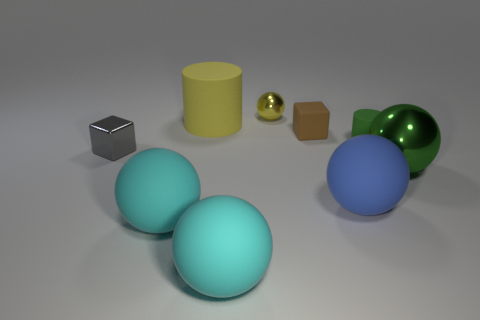How many gray things are either metal spheres or small metal cubes?
Ensure brevity in your answer.  1. What color is the small object that is both to the right of the tiny yellow thing and behind the green matte thing?
Make the answer very short. Brown. Do the tiny block that is behind the tiny green matte cylinder and the cylinder that is right of the blue matte sphere have the same material?
Offer a very short reply. Yes. Is the number of big blue rubber objects on the left side of the big green metallic sphere greater than the number of big cyan spheres right of the tiny brown object?
Provide a succinct answer. Yes. What is the shape of the yellow metal thing that is the same size as the brown matte thing?
Give a very brief answer. Sphere. What number of things are either green cylinders or big rubber objects that are right of the tiny brown matte block?
Provide a short and direct response. 2. Is the color of the big shiny thing the same as the small matte cylinder?
Offer a terse response. Yes. There is a large green thing; how many spheres are behind it?
Your response must be concise. 1. What is the color of the large cylinder that is made of the same material as the blue sphere?
Ensure brevity in your answer.  Yellow. What number of metallic things are either cylinders or big cyan objects?
Keep it short and to the point. 0. 